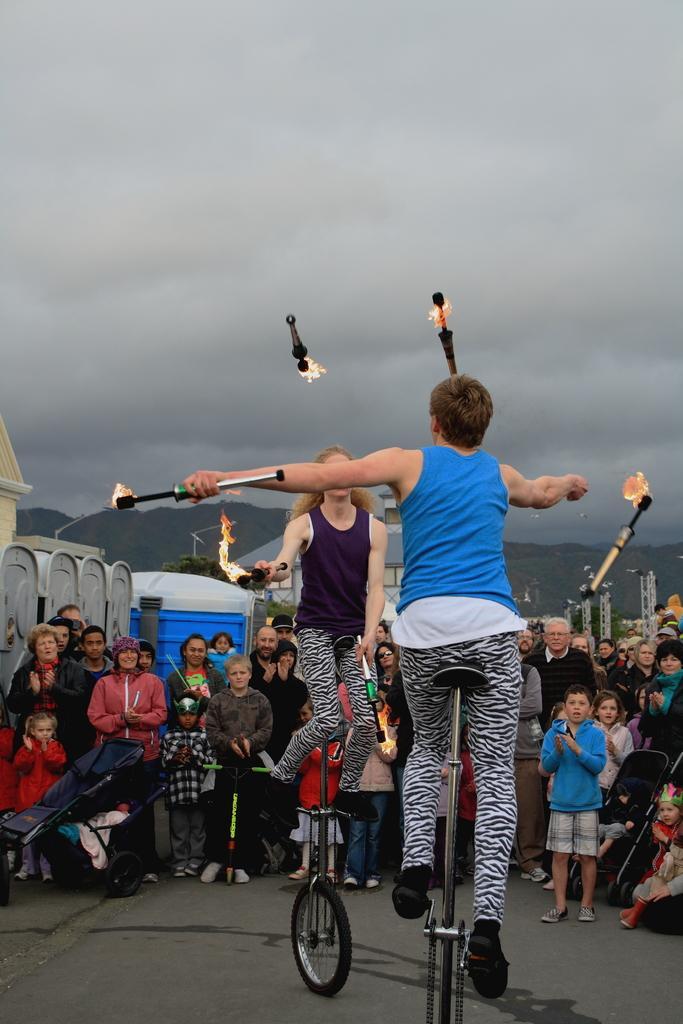Could you give a brief overview of what you see in this image? In this picture a woman is performing gymnastics, sitting on a bicycle holding an object in hand containing fire. and performing the task and here is a man playing with fire, here are group of people standing and looking. and sky is cloudy, and here are the mountains. 